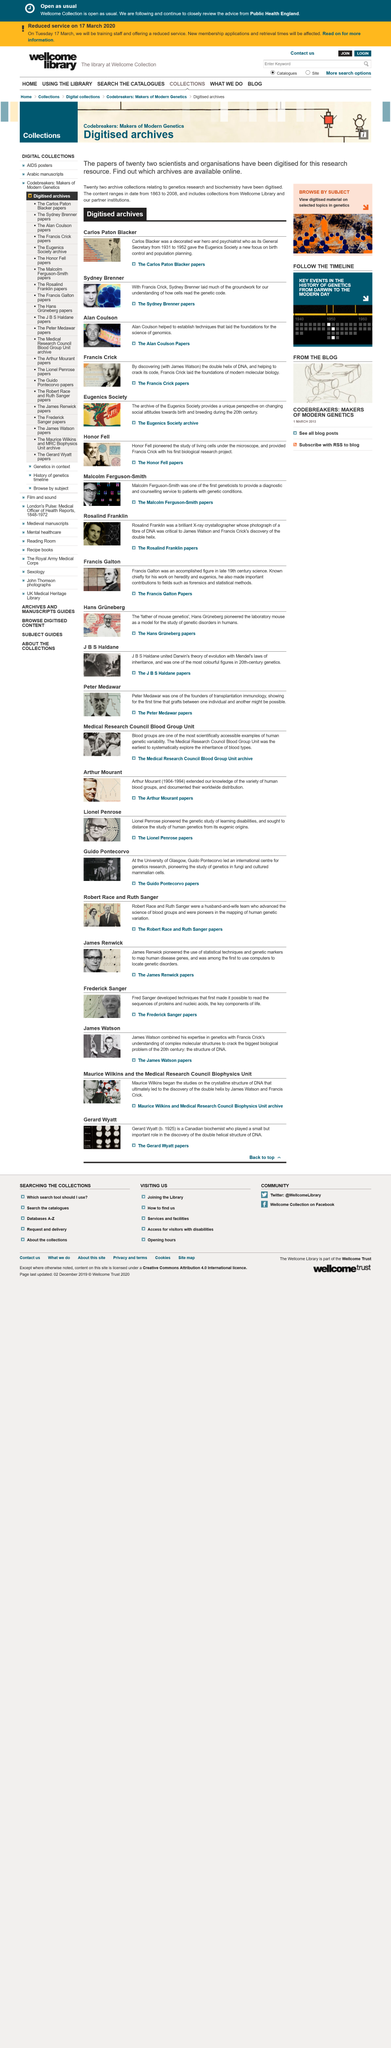Mention a couple of crucial points in this snapshot. The archives are accessible through the internet. Twenty-two scientists and organizations have been digitized. The digital archives contain two areas of interest, namely genetics research and biochemistry. 